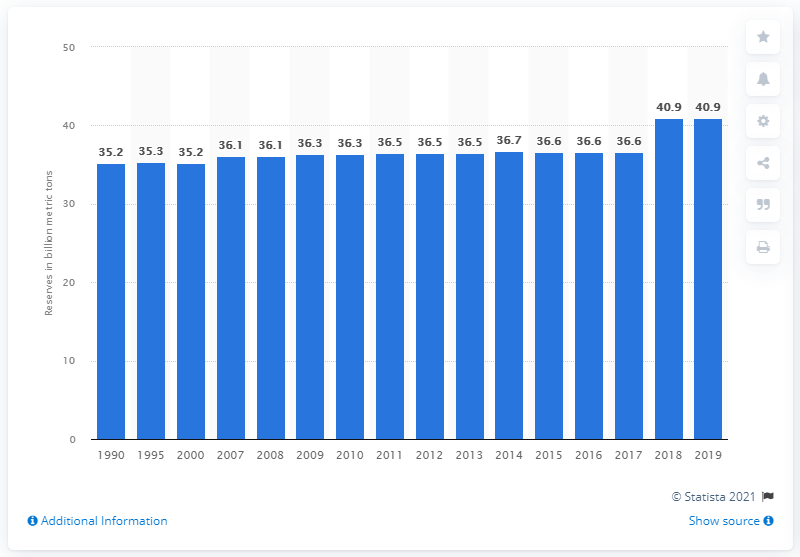Indicate a few pertinent items in this graphic. In 2019, Saudi Arabia's oil reserves were 40.9 billion barrels. 